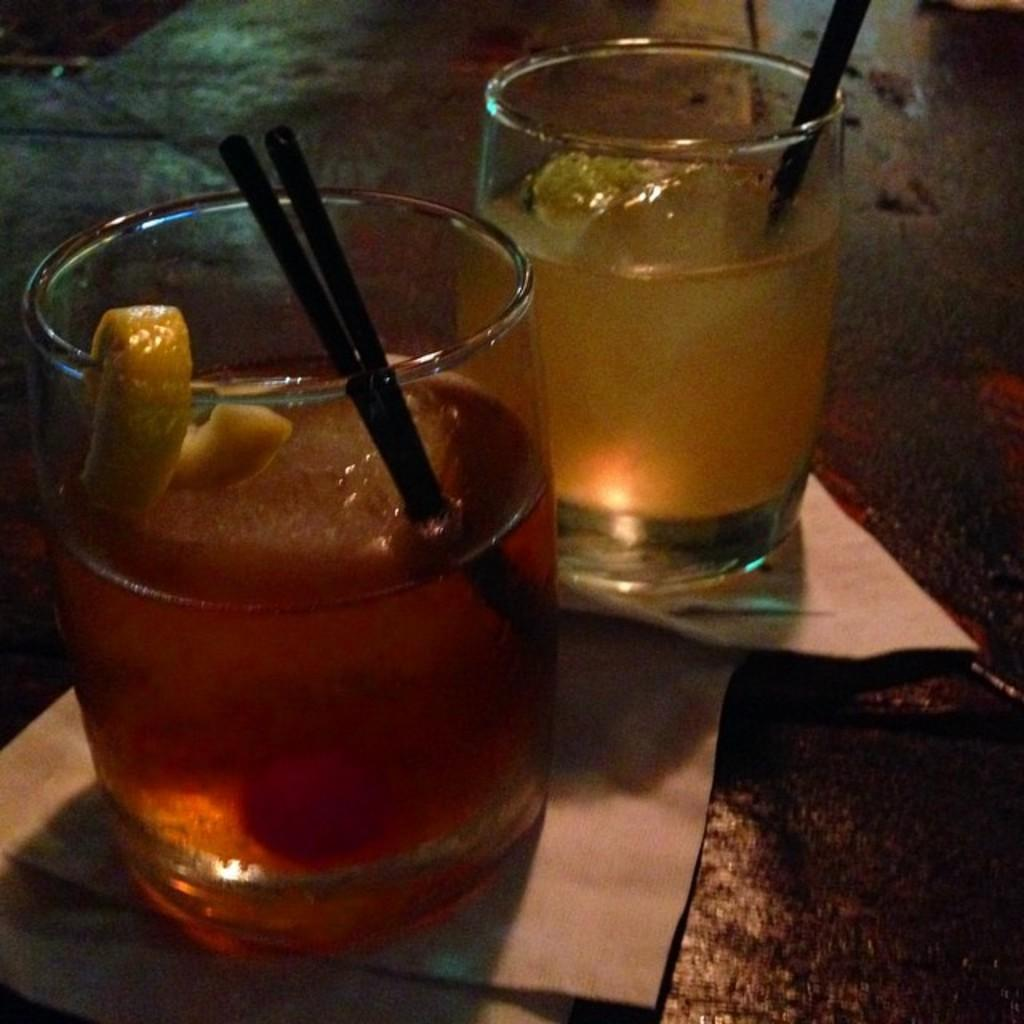What objects are on the papers in the image? There are two glasses on papers in the image. What is inside the glasses? There is a liquid inside the glasses. How are the people drinking the liquid in the glasses? Straws are present in the glasses, suggesting that they are being used to drink the liquid. What additional ingredient can be seen in the glasses? A piece of lemon is in the glasses. What type of sweater is being worn by the person in the image? There is no person present in the image, so it is not possible to determine what type of sweater they might be wearing. 